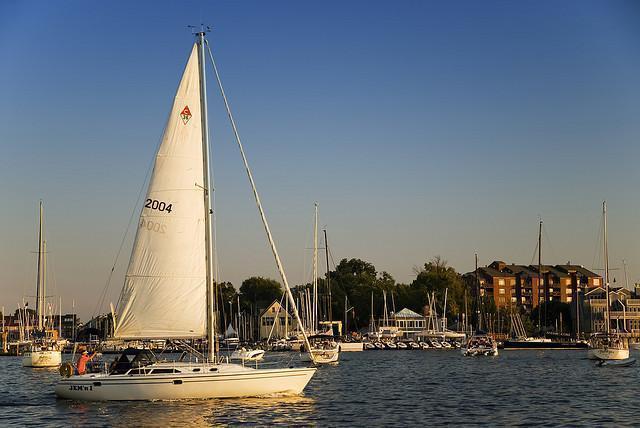What material is the sail mast made of?
Choose the right answer and clarify with the format: 'Answer: answer
Rationale: rationale.'
Options: Wood, aluminum, copper, iron. Answer: aluminum.
Rationale: The sail looks like it's sturdy without pulling the boat down. 